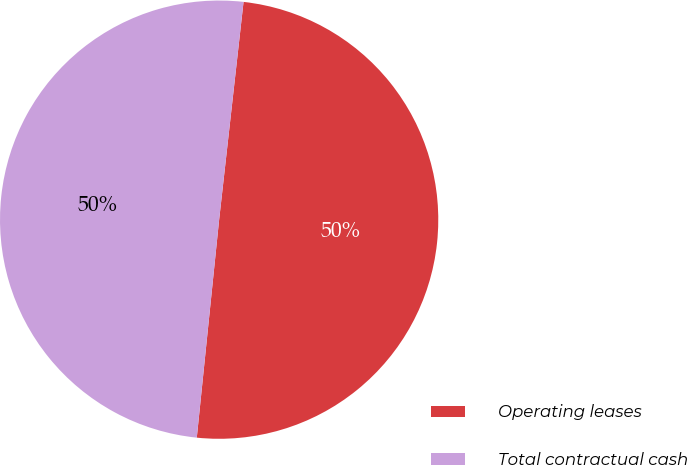Convert chart to OTSL. <chart><loc_0><loc_0><loc_500><loc_500><pie_chart><fcel>Operating leases<fcel>Total contractual cash<nl><fcel>49.85%<fcel>50.15%<nl></chart> 